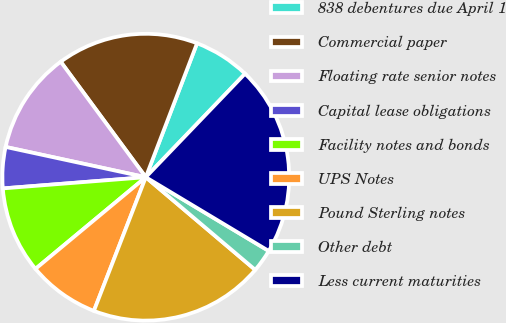<chart> <loc_0><loc_0><loc_500><loc_500><pie_chart><fcel>838 debentures due April 1<fcel>Commercial paper<fcel>Floating rate senior notes<fcel>Capital lease obligations<fcel>Facility notes and bonds<fcel>UPS Notes<fcel>Pound Sterling notes<fcel>Other debt<fcel>Less current maturities<nl><fcel>6.35%<fcel>15.92%<fcel>11.51%<fcel>4.63%<fcel>9.79%<fcel>8.07%<fcel>19.71%<fcel>2.58%<fcel>21.43%<nl></chart> 